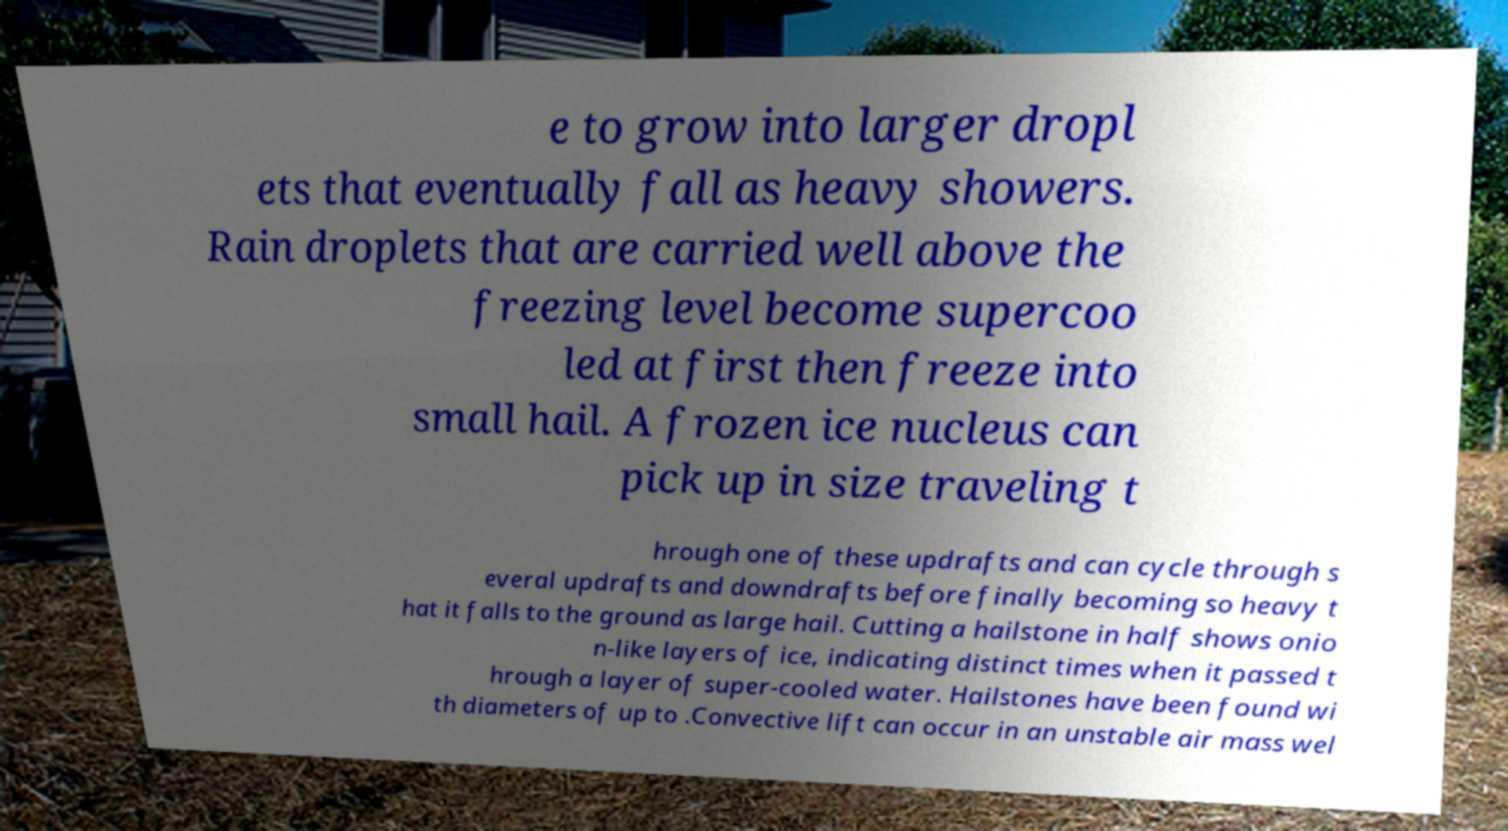What messages or text are displayed in this image? I need them in a readable, typed format. e to grow into larger dropl ets that eventually fall as heavy showers. Rain droplets that are carried well above the freezing level become supercoo led at first then freeze into small hail. A frozen ice nucleus can pick up in size traveling t hrough one of these updrafts and can cycle through s everal updrafts and downdrafts before finally becoming so heavy t hat it falls to the ground as large hail. Cutting a hailstone in half shows onio n-like layers of ice, indicating distinct times when it passed t hrough a layer of super-cooled water. Hailstones have been found wi th diameters of up to .Convective lift can occur in an unstable air mass wel 